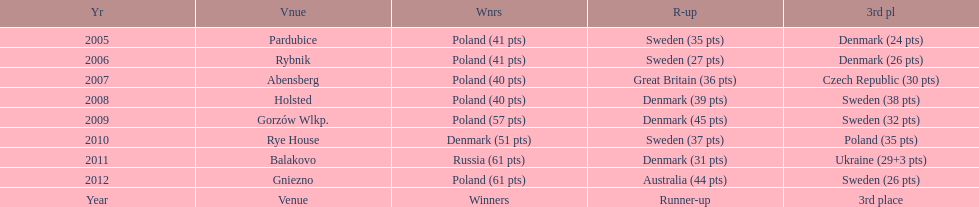In the speedway junior world championship, which team achieved the most third-place victories from 2005 to 2012? Sweden. 